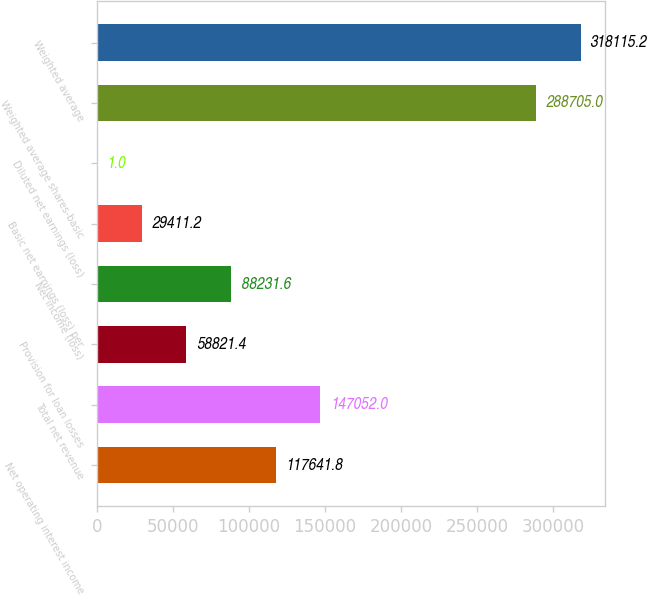Convert chart. <chart><loc_0><loc_0><loc_500><loc_500><bar_chart><fcel>Net operating interest income<fcel>Total net revenue<fcel>Provision for loan losses<fcel>Net income (loss)<fcel>Basic net earnings (loss) per<fcel>Diluted net earnings (loss)<fcel>Weighted average shares-basic<fcel>Weighted average<nl><fcel>117642<fcel>147052<fcel>58821.4<fcel>88231.6<fcel>29411.2<fcel>1<fcel>288705<fcel>318115<nl></chart> 